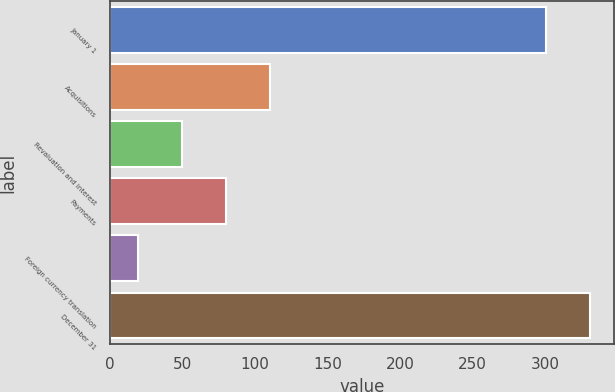<chart> <loc_0><loc_0><loc_500><loc_500><bar_chart><fcel>January 1<fcel>Acquisitions<fcel>Revaluation and interest<fcel>Payments<fcel>Foreign currency translation<fcel>December 31<nl><fcel>300.7<fcel>110.18<fcel>49.66<fcel>79.92<fcel>19.4<fcel>330.96<nl></chart> 